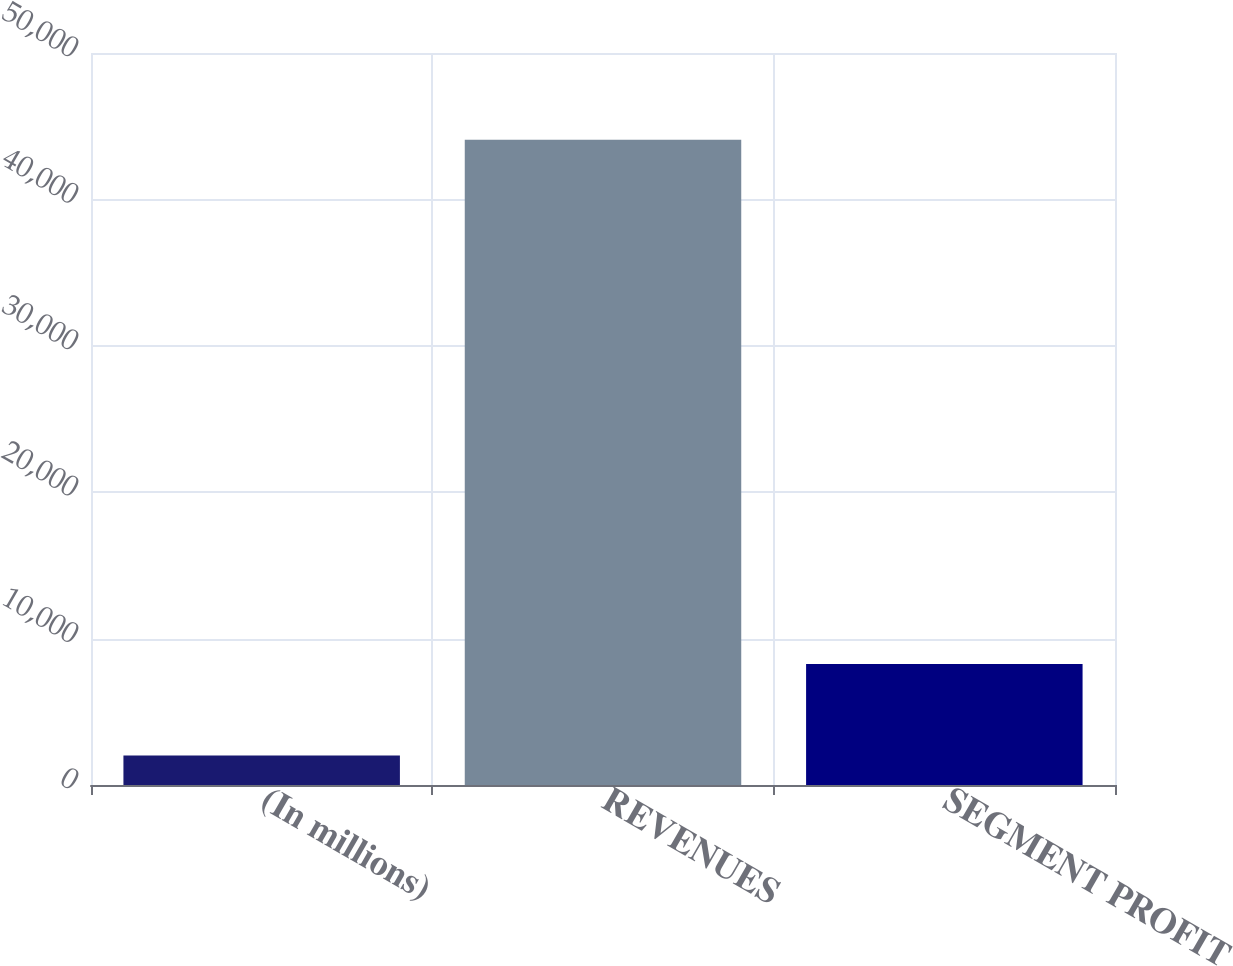<chart> <loc_0><loc_0><loc_500><loc_500><bar_chart><fcel>(In millions)<fcel>REVENUES<fcel>SEGMENT PROFIT<nl><fcel>2013<fcel>44067<fcel>8258<nl></chart> 